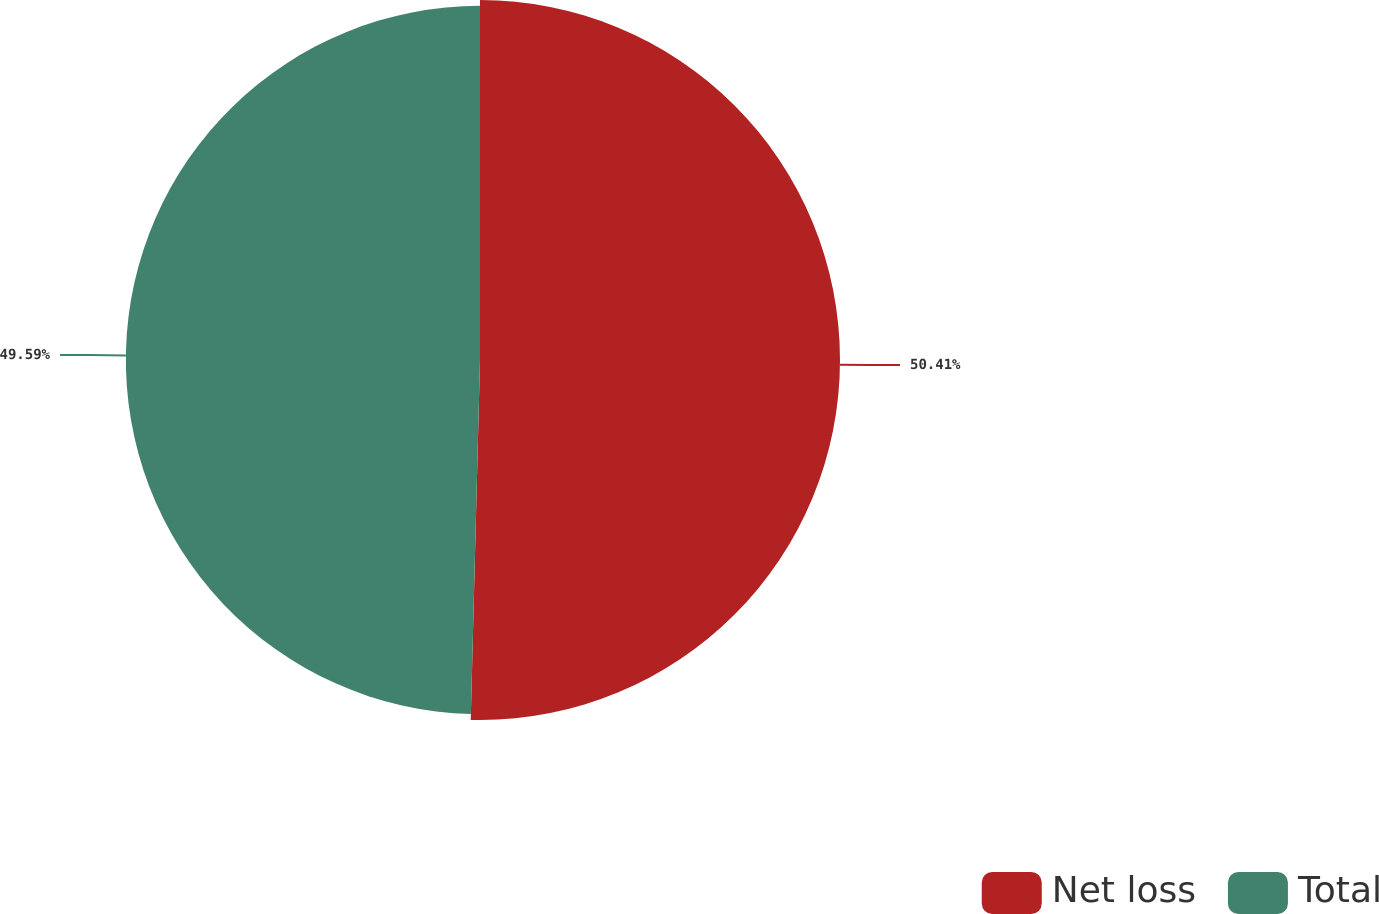<chart> <loc_0><loc_0><loc_500><loc_500><pie_chart><fcel>Net loss<fcel>Total<nl><fcel>50.41%<fcel>49.59%<nl></chart> 